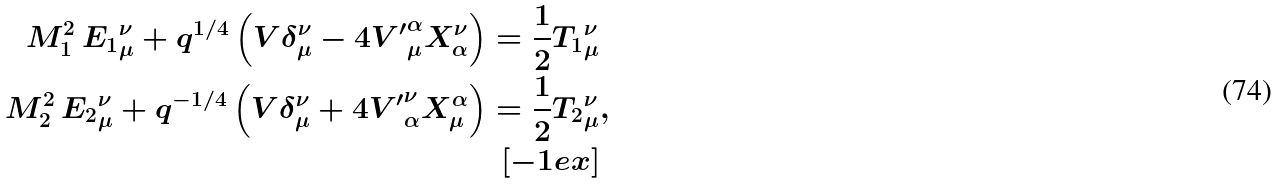<formula> <loc_0><loc_0><loc_500><loc_500>M _ { 1 } ^ { 2 } \, { E _ { 1 } } _ { \mu } ^ { \nu } + q ^ { 1 / 4 } \left ( V \delta _ { \mu } ^ { \nu } - 4 { V ^ { \prime } } _ { \mu } ^ { \alpha } X _ { \alpha } ^ { \nu } \right ) = \frac { 1 } { 2 } { T _ { 1 } } _ { \mu } ^ { \nu } & \\ M _ { 2 } ^ { 2 } \, { E _ { 2 } } _ { \mu } ^ { \nu } + q ^ { - 1 / 4 } \left ( V \delta _ { \mu } ^ { \nu } + 4 { V ^ { \prime } } ^ { \nu } _ { \alpha } X ^ { \alpha } _ { \mu } \right ) = \frac { 1 } { 2 } { T _ { 2 } } _ { \mu } ^ { \nu } & , \\ [ - 1 e x ]</formula> 